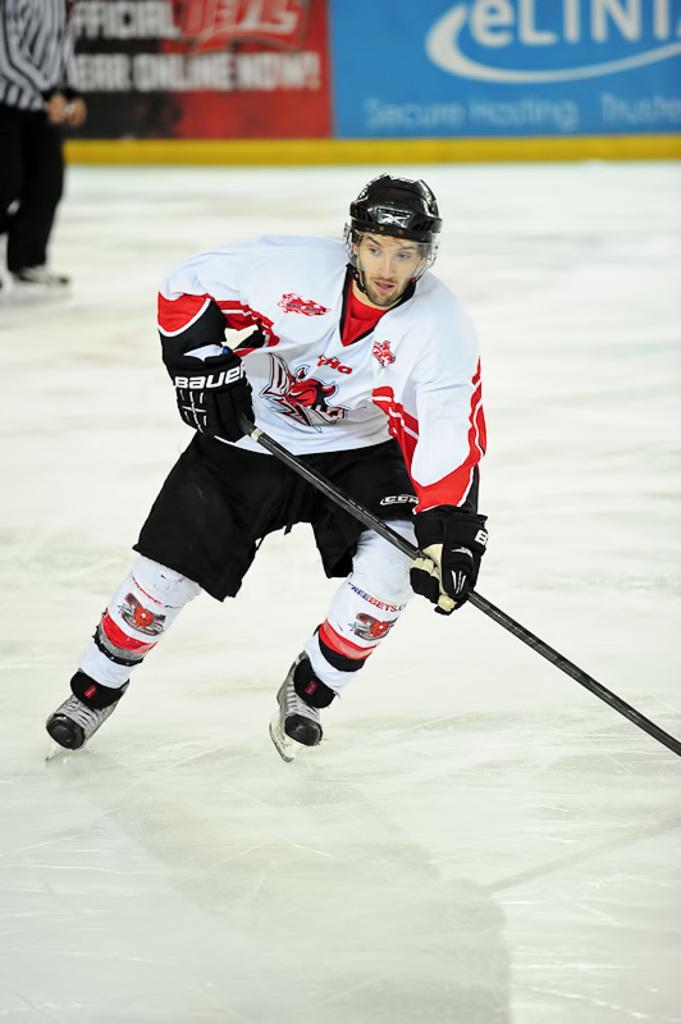Can you describe this image briefly? In this image I can see a person is skating and holding stick. The person is wearing white, red and black color dress. Back I can see another person and few colorful boards. 